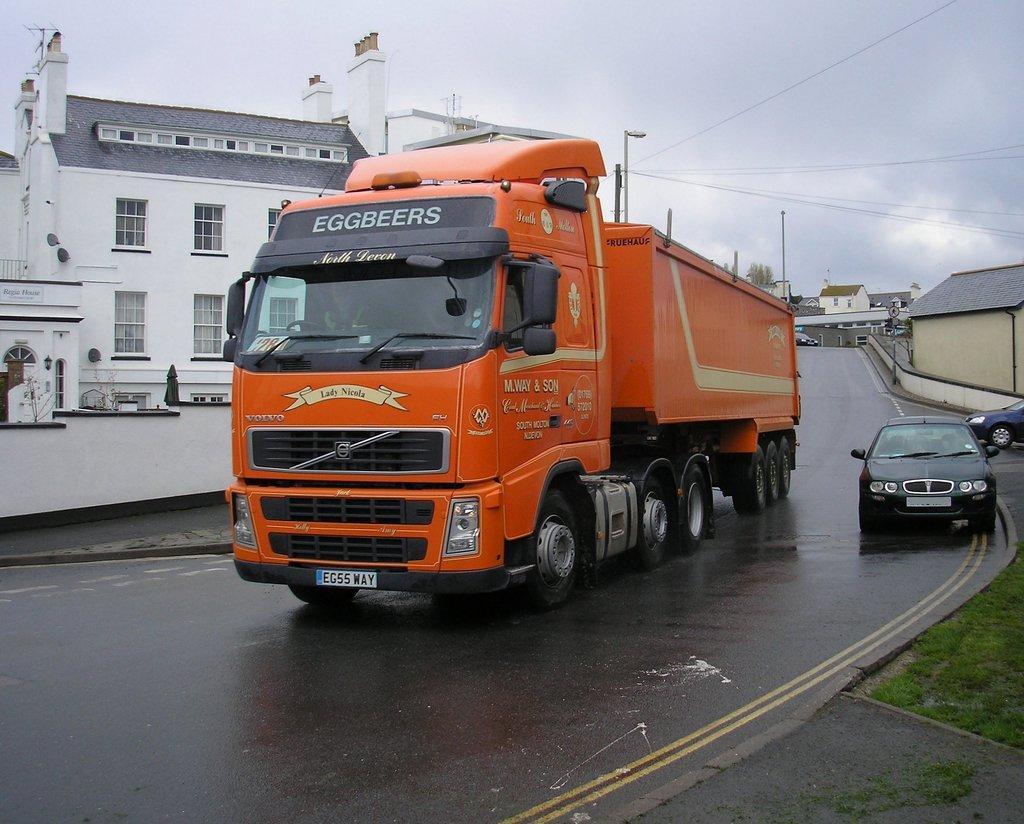Could you give a brief overview of what you see in this image? In the center of the image we can see vehicles on the road. In the background there are buildings, poles, wires and sky. 